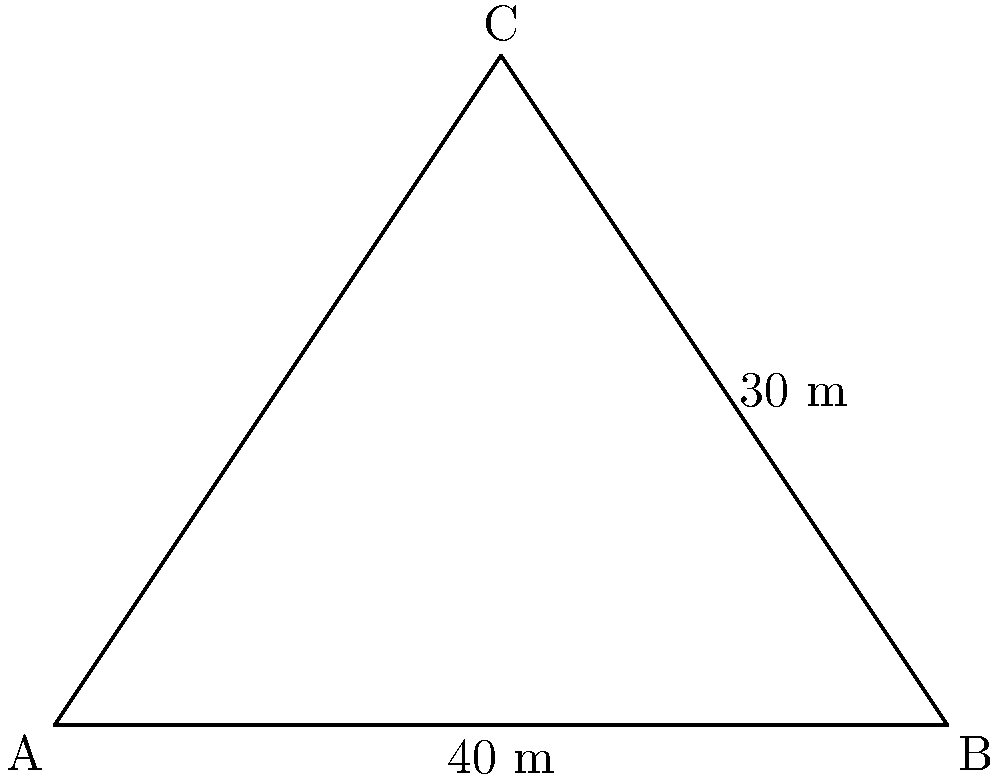As a tourism consultant in Atlanta, you're assessing a new pyramid-shaped building in the city center for potential visitor attractions. The building has a square base with sides measuring 40 meters and a height of 30 meters. What is the total surface area of this pyramid-shaped structure, including the base? To calculate the total surface area of the pyramid, we need to find the area of the square base and the areas of the four triangular faces, then sum them up.

Step 1: Calculate the area of the square base.
Base area = $40 \text{ m} \times 40 \text{ m} = 1600 \text{ m}^2$

Step 2: Calculate the slant height of the pyramid using the Pythagorean theorem.
Half of the base diagonal = $\sqrt{(40 \text{ m}/2)^2 + (40 \text{ m}/2)^2} = 20\sqrt{2} \text{ m}$
Slant height = $\sqrt{(20\sqrt{2} \text{ m})^2 + (30 \text{ m})^2} = \sqrt{800 + 900} = \sqrt{1700} \text{ m}$

Step 3: Calculate the area of one triangular face.
Area of one face = $\frac{1}{2} \times 40 \text{ m} \times \sqrt{1700} \text{ m} = 20\sqrt{1700} \text{ m}^2$

Step 4: Calculate the total area of the four triangular faces.
Total area of faces = $4 \times 20\sqrt{1700} \text{ m}^2 = 80\sqrt{1700} \text{ m}^2$

Step 5: Sum up the areas to get the total surface area.
Total surface area = Base area + Total area of faces
$= 1600 \text{ m}^2 + 80\sqrt{1700} \text{ m}^2$
$= (1600 + 80\sqrt{1700}) \text{ m}^2$

Therefore, the total surface area of the pyramid-shaped building is $(1600 + 80\sqrt{1700}) \text{ m}^2$.
Answer: $(1600 + 80\sqrt{1700}) \text{ m}^2$ 